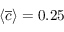Convert formula to latex. <formula><loc_0><loc_0><loc_500><loc_500>\langle \overline { c } \rangle = 0 . 2 5</formula> 